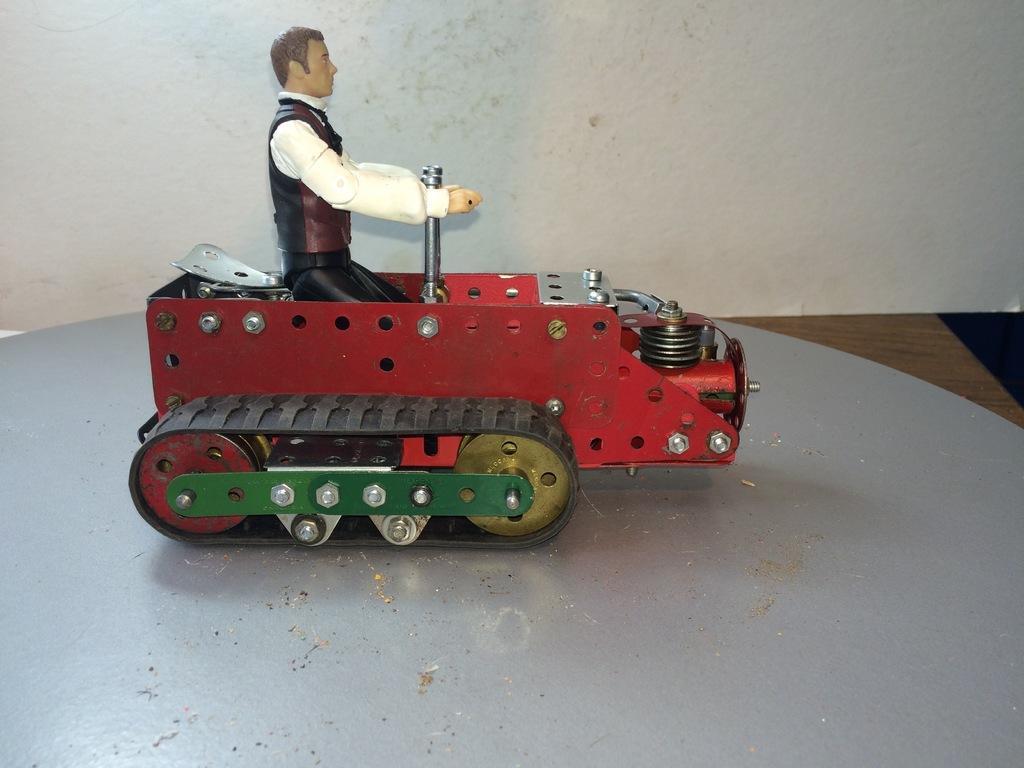Could you give a brief overview of what you see in this image? In this image I can see a toy in the crawler vehicle. I can see the wooden table on the right side. In the background, I can see the wall. 